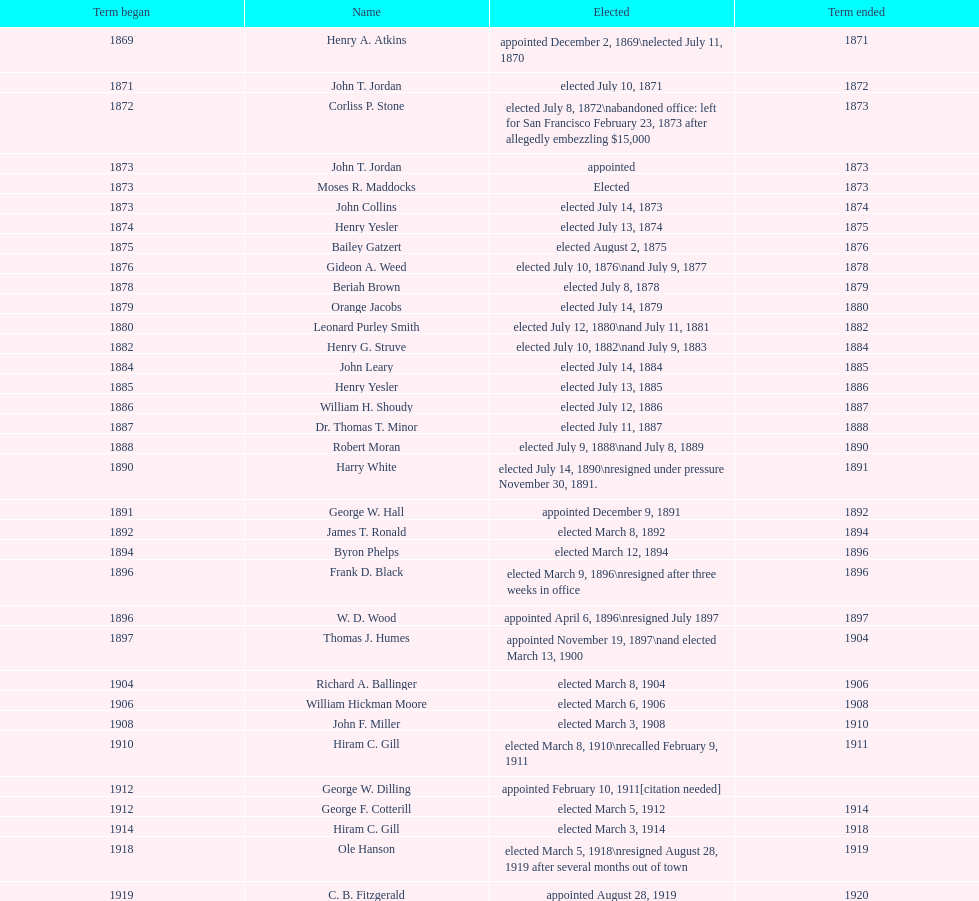Who was the only person elected in 1871? John T. Jordan. 